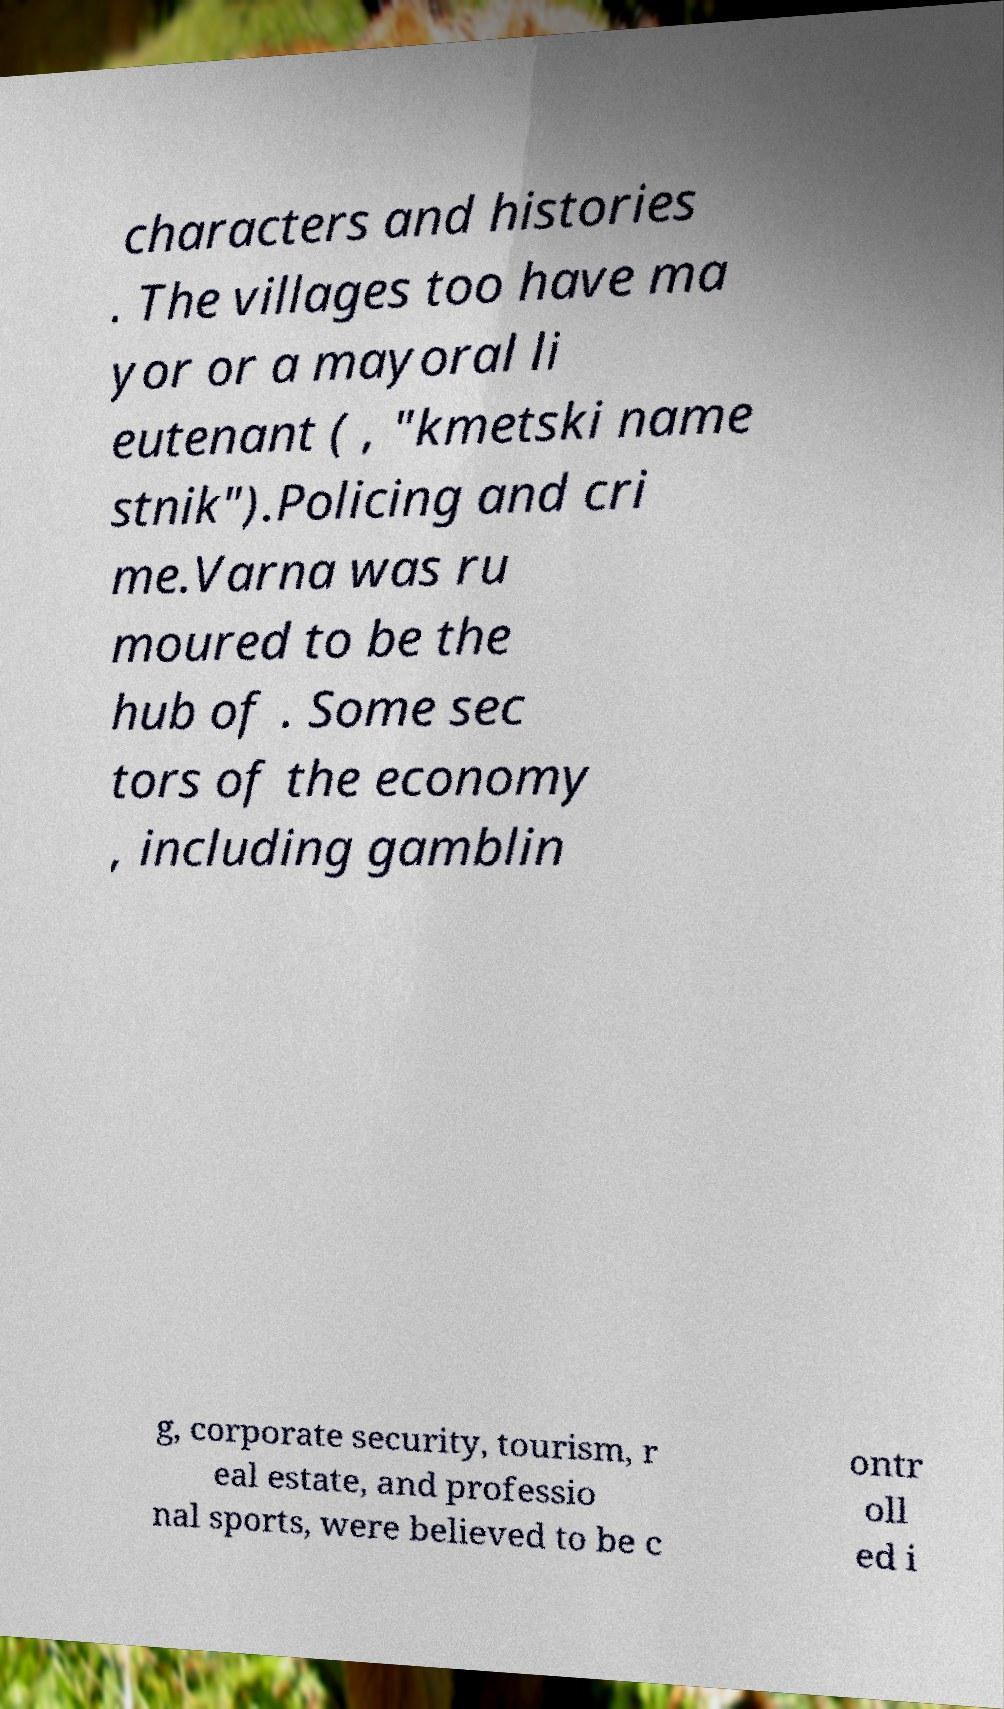Could you assist in decoding the text presented in this image and type it out clearly? characters and histories . The villages too have ma yor or a mayoral li eutenant ( , "kmetski name stnik").Policing and cri me.Varna was ru moured to be the hub of . Some sec tors of the economy , including gamblin g, corporate security, tourism, r eal estate, and professio nal sports, were believed to be c ontr oll ed i 